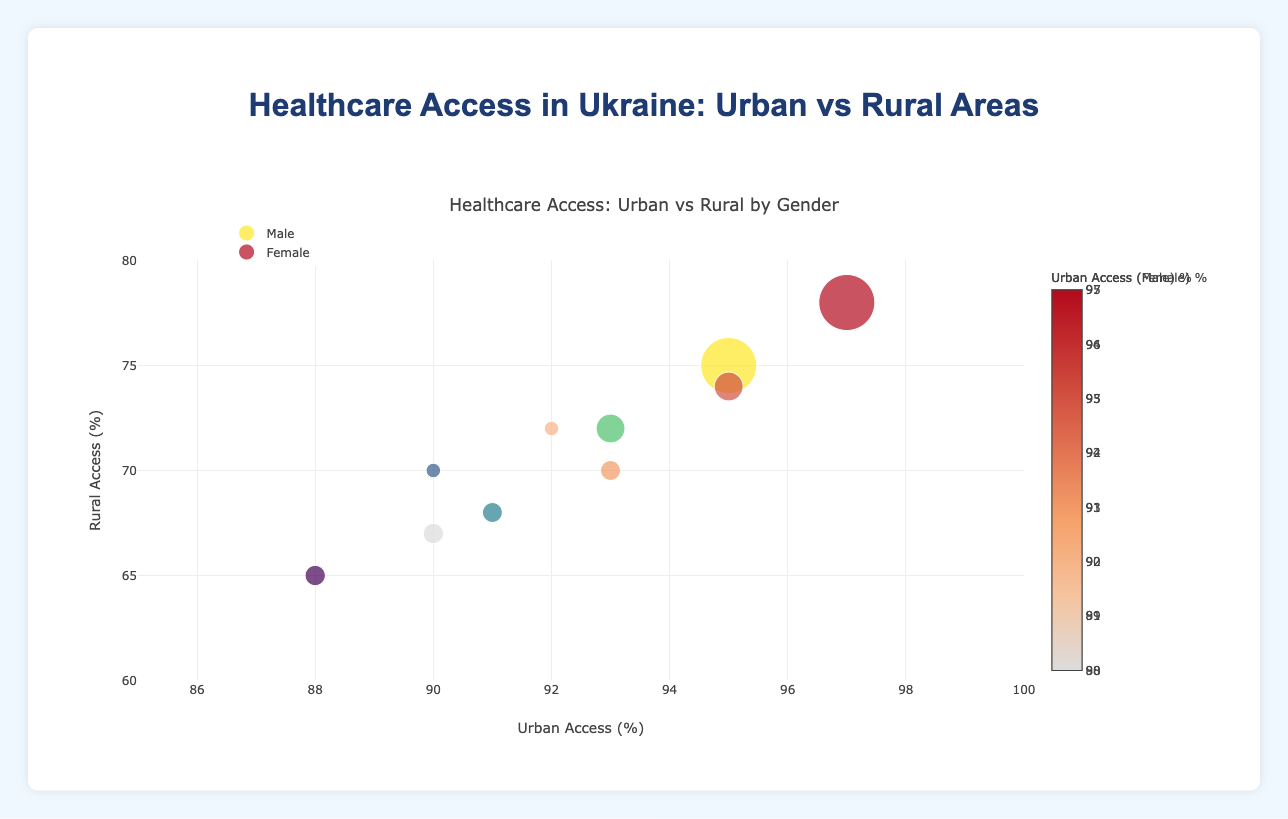What is the overall title of the chart? The main title is displayed at the top of the chart. It reads "Healthcare Access: Urban vs Rural by Gender".
Answer: Healthcare Access: Urban vs Rural by Gender How many regions are represented in the bubble chart? Each bubble represents one region. According to the data, there are 5 regions shown in the chart.
Answer: 5 Which region has the highest urban healthcare access percentage for females? We look at the x-axis for female urban access and identify the highest percentage, then check the region. It's Kyiv with 97%.
Answer: Kyiv What is the rural healthcare access percentage for males in the Dnipro region? Find Dnipro's bubble for males, and check the y-axis value for rural access. It's 68%.
Answer: 68% What region has the largest population size? The bubble's size is proportional to the population. The largest bubble corresponds to Kyiv with a population of 2,800,000.
Answer: Kyiv By how many percentage points does rural female access in Kyiv exceed male access in Kyiv? Locate Kyiv's rural access for both genders (78% for females and 75% for males). Subtract the male percentage from the female percentage. The difference is 78 - 75 = 3 percentage points.
Answer: 3 Compare urban female healthcare access between Lviv and Odessa. Which one is higher and by how much? Check x-axis values for urban female access in Lviv and Odessa. Lviv is 92%, and Odessa is 90%. Lviv exceeds Odessa by 92 - 90 = 2 percentage points.
Answer: Lviv, 2 Which gender in the Kharkiv region has higher rural healthcare access, and by how much? For Kharkiv, the rural access for females is 74% and males is 72%. Calculate the difference as 74 - 72 = 2 percentage points, with females having higher access.
Answer: Female, 2 What is the difference between the highest urban healthcare access and the lowest rural healthcare access? Identify the highest urban access (97% in Kyiv for females) and the lowest rural access (65% in Odessa for males). Subtract the lowest from the highest: 97 - 65 = 32 percentage points.
Answer: 32 Which region shows the smallest gender disparity in urban healthcare access? Calculate the urban access differences between genders for each region and compare. Kyiv has a disparity of 97 - 95 = 2 percentage points, which is the smallest.
Answer: Kyiv 